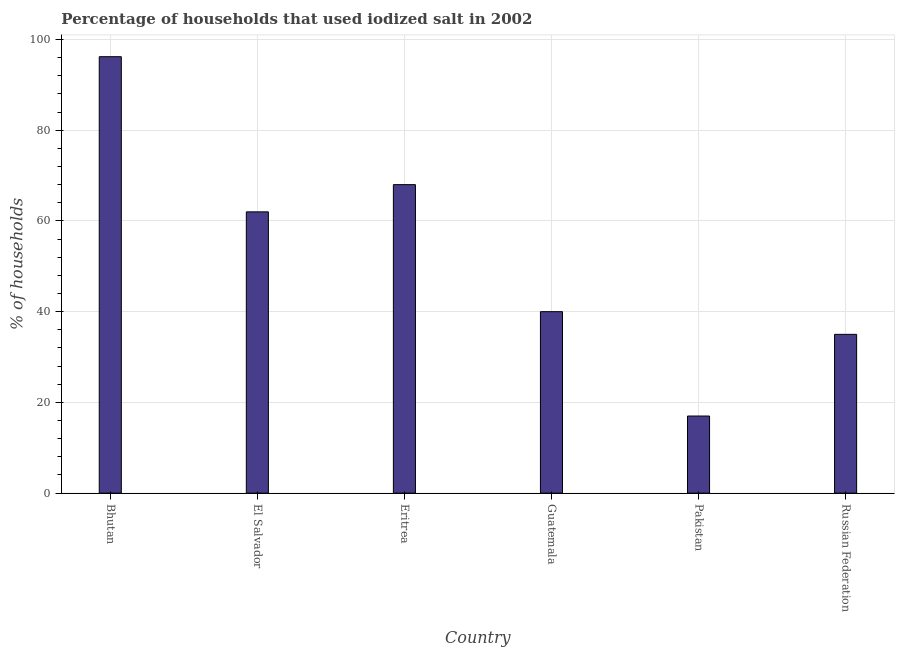Does the graph contain any zero values?
Your answer should be compact. No. Does the graph contain grids?
Keep it short and to the point. Yes. What is the title of the graph?
Keep it short and to the point. Percentage of households that used iodized salt in 2002. What is the label or title of the Y-axis?
Ensure brevity in your answer.  % of households. What is the percentage of households where iodized salt is consumed in Pakistan?
Offer a very short reply. 17. Across all countries, what is the maximum percentage of households where iodized salt is consumed?
Give a very brief answer. 96.2. Across all countries, what is the minimum percentage of households where iodized salt is consumed?
Provide a succinct answer. 17. In which country was the percentage of households where iodized salt is consumed maximum?
Offer a very short reply. Bhutan. What is the sum of the percentage of households where iodized salt is consumed?
Your response must be concise. 318.2. What is the difference between the percentage of households where iodized salt is consumed in Bhutan and El Salvador?
Provide a short and direct response. 34.2. What is the average percentage of households where iodized salt is consumed per country?
Your answer should be very brief. 53.03. What is the ratio of the percentage of households where iodized salt is consumed in Bhutan to that in Eritrea?
Offer a very short reply. 1.42. Is the percentage of households where iodized salt is consumed in Eritrea less than that in Guatemala?
Your answer should be very brief. No. Is the difference between the percentage of households where iodized salt is consumed in Pakistan and Russian Federation greater than the difference between any two countries?
Provide a short and direct response. No. What is the difference between the highest and the second highest percentage of households where iodized salt is consumed?
Provide a short and direct response. 28.2. Is the sum of the percentage of households where iodized salt is consumed in Guatemala and Pakistan greater than the maximum percentage of households where iodized salt is consumed across all countries?
Offer a very short reply. No. What is the difference between the highest and the lowest percentage of households where iodized salt is consumed?
Offer a terse response. 79.2. How many bars are there?
Provide a succinct answer. 6. How many countries are there in the graph?
Make the answer very short. 6. What is the % of households in Bhutan?
Your answer should be compact. 96.2. What is the % of households of Pakistan?
Your response must be concise. 17. What is the difference between the % of households in Bhutan and El Salvador?
Provide a succinct answer. 34.2. What is the difference between the % of households in Bhutan and Eritrea?
Your answer should be very brief. 28.2. What is the difference between the % of households in Bhutan and Guatemala?
Make the answer very short. 56.2. What is the difference between the % of households in Bhutan and Pakistan?
Give a very brief answer. 79.2. What is the difference between the % of households in Bhutan and Russian Federation?
Keep it short and to the point. 61.2. What is the difference between the % of households in El Salvador and Guatemala?
Your answer should be very brief. 22. What is the difference between the % of households in El Salvador and Pakistan?
Make the answer very short. 45. What is the difference between the % of households in Eritrea and Guatemala?
Your response must be concise. 28. What is the difference between the % of households in Eritrea and Russian Federation?
Your answer should be very brief. 33. What is the difference between the % of households in Guatemala and Pakistan?
Give a very brief answer. 23. What is the ratio of the % of households in Bhutan to that in El Salvador?
Your response must be concise. 1.55. What is the ratio of the % of households in Bhutan to that in Eritrea?
Keep it short and to the point. 1.42. What is the ratio of the % of households in Bhutan to that in Guatemala?
Provide a short and direct response. 2.4. What is the ratio of the % of households in Bhutan to that in Pakistan?
Your answer should be compact. 5.66. What is the ratio of the % of households in Bhutan to that in Russian Federation?
Offer a very short reply. 2.75. What is the ratio of the % of households in El Salvador to that in Eritrea?
Your answer should be very brief. 0.91. What is the ratio of the % of households in El Salvador to that in Guatemala?
Give a very brief answer. 1.55. What is the ratio of the % of households in El Salvador to that in Pakistan?
Provide a succinct answer. 3.65. What is the ratio of the % of households in El Salvador to that in Russian Federation?
Your answer should be very brief. 1.77. What is the ratio of the % of households in Eritrea to that in Guatemala?
Offer a very short reply. 1.7. What is the ratio of the % of households in Eritrea to that in Pakistan?
Make the answer very short. 4. What is the ratio of the % of households in Eritrea to that in Russian Federation?
Offer a terse response. 1.94. What is the ratio of the % of households in Guatemala to that in Pakistan?
Provide a short and direct response. 2.35. What is the ratio of the % of households in Guatemala to that in Russian Federation?
Offer a very short reply. 1.14. What is the ratio of the % of households in Pakistan to that in Russian Federation?
Ensure brevity in your answer.  0.49. 